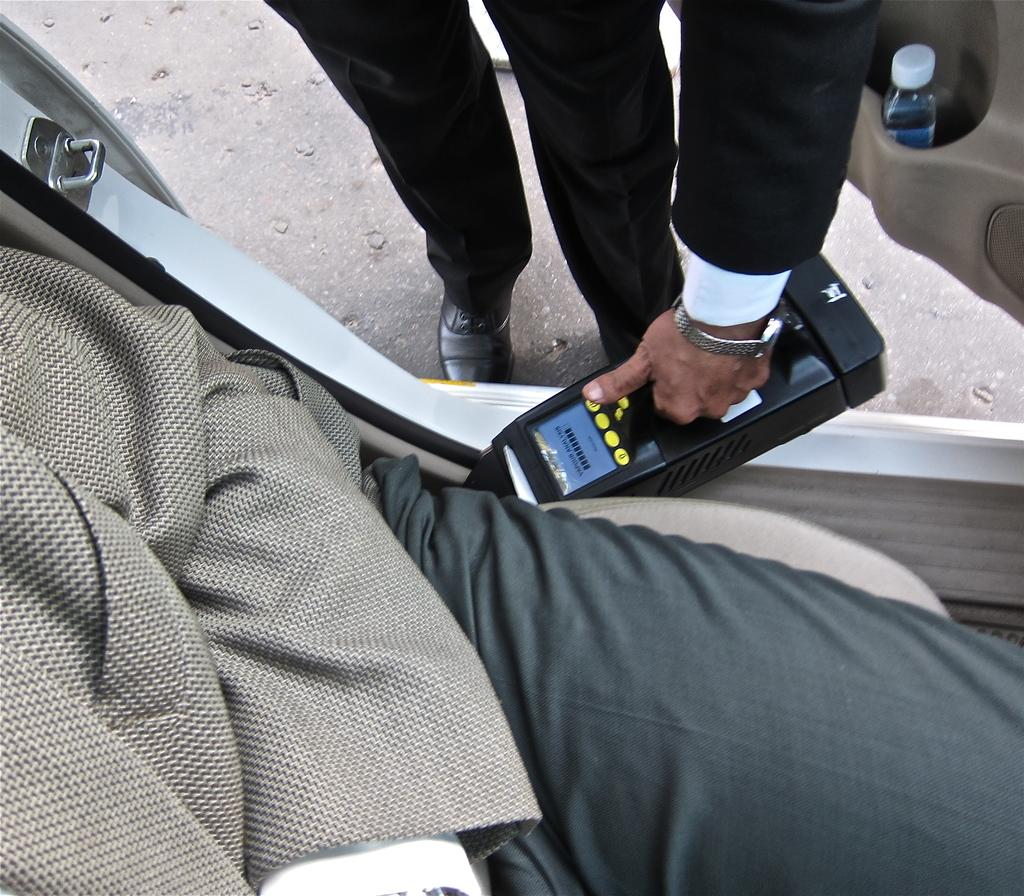How many people are in the image? There are two people in the image. What is one person doing in the image? One person is sitting in a vehicle. What is the person sitting in the vehicle holding? The person in the vehicle is holding something. Can you identify any objects in the image besides the people? Yes, there is a bottle visible in the image. What type of honey can be seen dripping from the rat in the image? There is no rat or honey present in the image. Can you describe the snake's behavior in the image? There is no snake present in the image. 